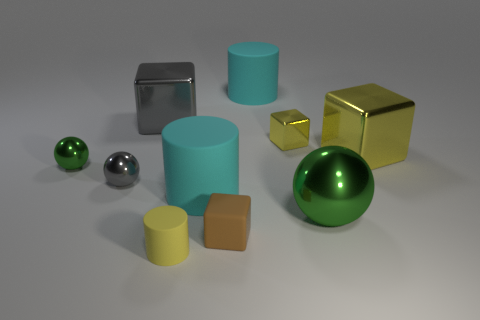Are there the same number of tiny brown rubber cubes in front of the tiny rubber block and tiny cubes in front of the small yellow shiny thing?
Keep it short and to the point. No. What number of large gray things are the same material as the large green sphere?
Give a very brief answer. 1. The tiny object that is the same color as the tiny cylinder is what shape?
Give a very brief answer. Cube. What is the size of the cylinder in front of the matte cube in front of the tiny yellow metal object?
Make the answer very short. Small. Does the yellow object on the right side of the big sphere have the same shape as the small shiny object that is on the right side of the small gray object?
Give a very brief answer. Yes. Are there an equal number of metallic spheres that are in front of the tiny cylinder and purple matte cylinders?
Provide a succinct answer. Yes. The large object that is the same shape as the small green object is what color?
Your response must be concise. Green. Does the cyan cylinder that is behind the big gray shiny cube have the same material as the brown block?
Offer a very short reply. Yes. How many tiny objects are either red blocks or cyan rubber things?
Ensure brevity in your answer.  0. What size is the matte cube?
Make the answer very short. Small. 